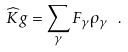<formula> <loc_0><loc_0><loc_500><loc_500>\widehat { K } g = \sum _ { \gamma } F _ { \gamma } \rho _ { \gamma } \ .</formula> 